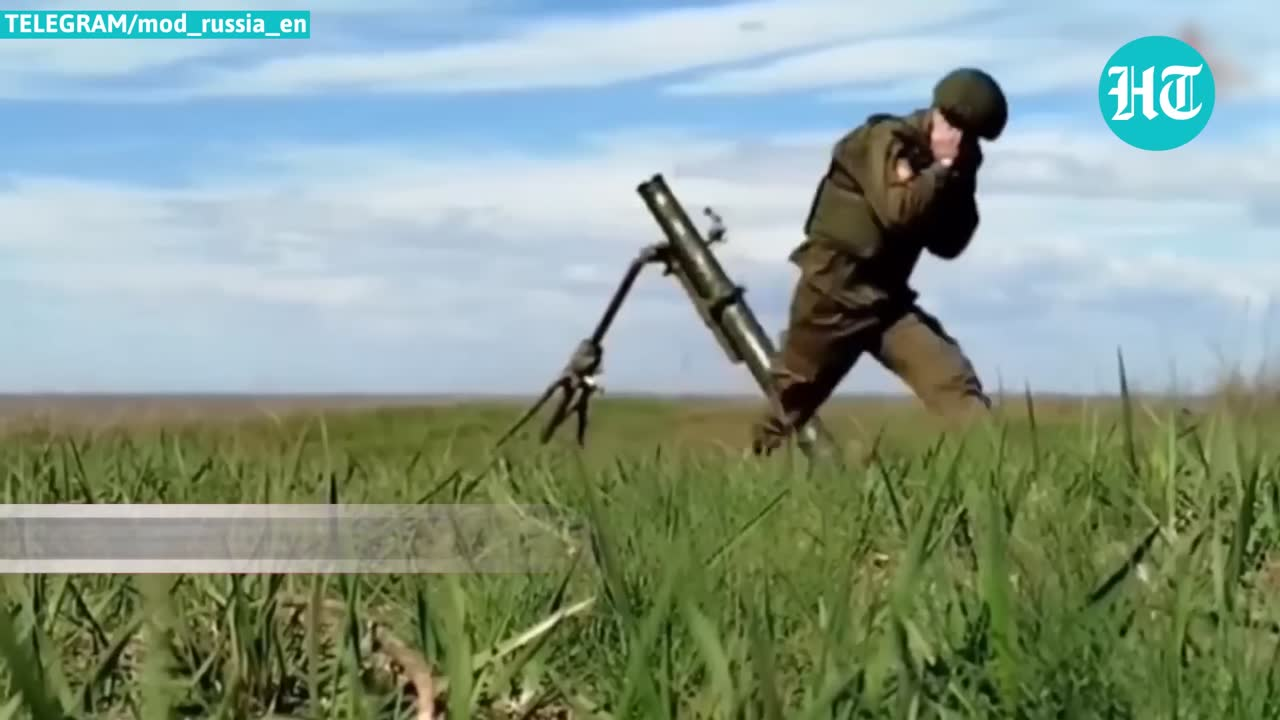list out what objects  this img show This image shows a soldier in military uniform operating a mortar or artillery weapon in a grassy field. The soldier appears to be aiming or firing the weapon, which is mounted on a tripod. The background shows an open field with a cloudy sky. 